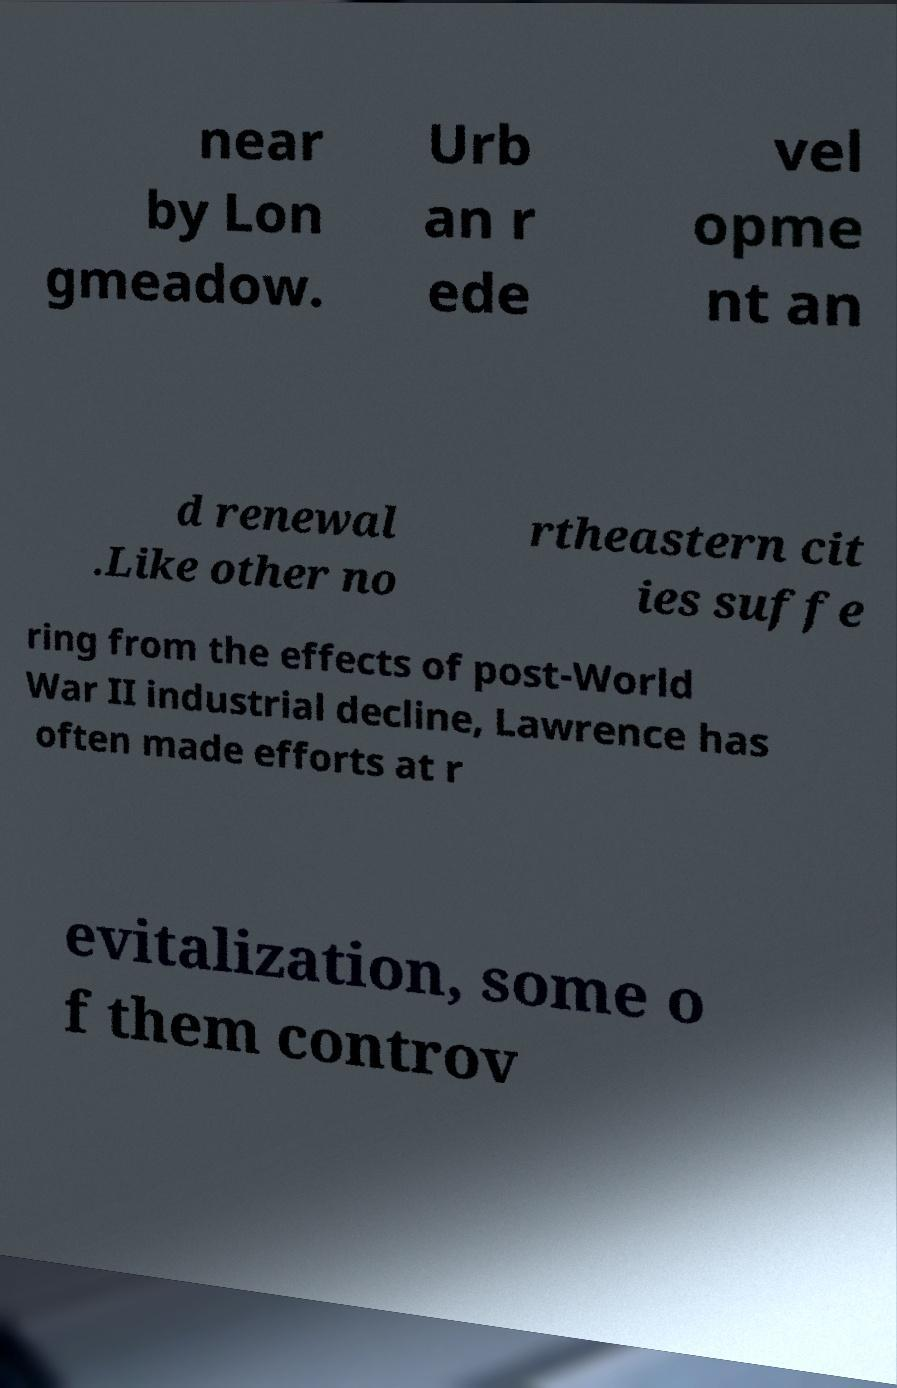For documentation purposes, I need the text within this image transcribed. Could you provide that? near by Lon gmeadow. Urb an r ede vel opme nt an d renewal .Like other no rtheastern cit ies suffe ring from the effects of post-World War II industrial decline, Lawrence has often made efforts at r evitalization, some o f them controv 